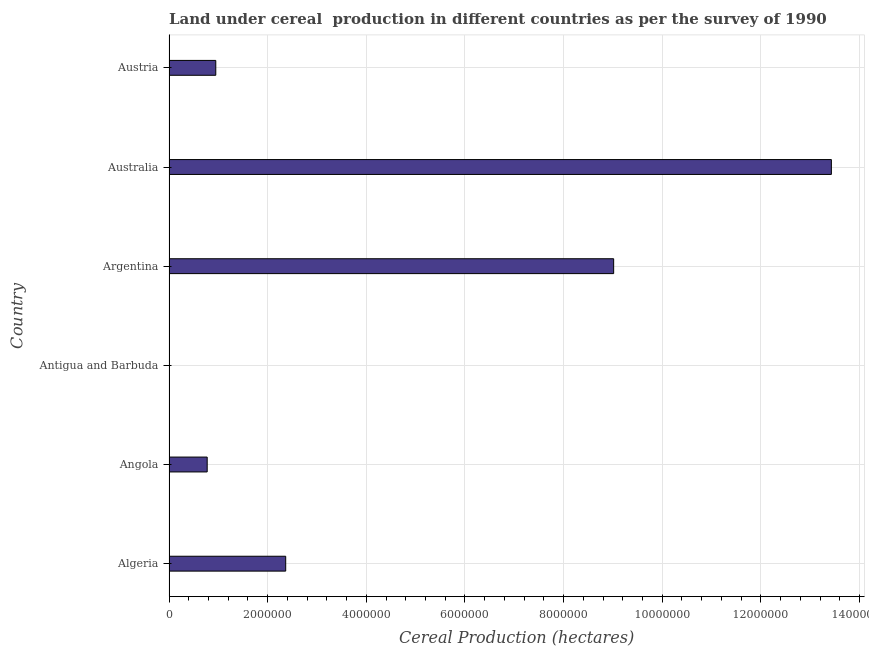Does the graph contain any zero values?
Your answer should be very brief. No. What is the title of the graph?
Provide a short and direct response. Land under cereal  production in different countries as per the survey of 1990. What is the label or title of the X-axis?
Your response must be concise. Cereal Production (hectares). What is the land under cereal production in Australia?
Your answer should be very brief. 1.34e+07. Across all countries, what is the maximum land under cereal production?
Your answer should be very brief. 1.34e+07. Across all countries, what is the minimum land under cereal production?
Provide a succinct answer. 21. In which country was the land under cereal production maximum?
Provide a succinct answer. Australia. In which country was the land under cereal production minimum?
Your response must be concise. Antigua and Barbuda. What is the sum of the land under cereal production?
Provide a short and direct response. 2.65e+07. What is the difference between the land under cereal production in Antigua and Barbuda and Austria?
Make the answer very short. -9.48e+05. What is the average land under cereal production per country?
Ensure brevity in your answer.  4.42e+06. What is the median land under cereal production?
Provide a short and direct response. 1.66e+06. In how many countries, is the land under cereal production greater than 9600000 hectares?
Provide a short and direct response. 1. What is the ratio of the land under cereal production in Algeria to that in Angola?
Keep it short and to the point. 3.06. Is the difference between the land under cereal production in Algeria and Angola greater than the difference between any two countries?
Provide a short and direct response. No. What is the difference between the highest and the second highest land under cereal production?
Give a very brief answer. 4.41e+06. What is the difference between the highest and the lowest land under cereal production?
Offer a very short reply. 1.34e+07. In how many countries, is the land under cereal production greater than the average land under cereal production taken over all countries?
Your answer should be very brief. 2. How many bars are there?
Ensure brevity in your answer.  6. Are the values on the major ticks of X-axis written in scientific E-notation?
Make the answer very short. No. What is the Cereal Production (hectares) of Algeria?
Offer a terse response. 2.37e+06. What is the Cereal Production (hectares) in Angola?
Keep it short and to the point. 7.74e+05. What is the Cereal Production (hectares) of Argentina?
Offer a terse response. 9.01e+06. What is the Cereal Production (hectares) in Australia?
Provide a short and direct response. 1.34e+07. What is the Cereal Production (hectares) of Austria?
Ensure brevity in your answer.  9.48e+05. What is the difference between the Cereal Production (hectares) in Algeria and Angola?
Make the answer very short. 1.59e+06. What is the difference between the Cereal Production (hectares) in Algeria and Antigua and Barbuda?
Provide a short and direct response. 2.37e+06. What is the difference between the Cereal Production (hectares) in Algeria and Argentina?
Offer a very short reply. -6.65e+06. What is the difference between the Cereal Production (hectares) in Algeria and Australia?
Your response must be concise. -1.11e+07. What is the difference between the Cereal Production (hectares) in Algeria and Austria?
Offer a very short reply. 1.42e+06. What is the difference between the Cereal Production (hectares) in Angola and Antigua and Barbuda?
Provide a succinct answer. 7.74e+05. What is the difference between the Cereal Production (hectares) in Angola and Argentina?
Offer a terse response. -8.24e+06. What is the difference between the Cereal Production (hectares) in Angola and Australia?
Your response must be concise. -1.27e+07. What is the difference between the Cereal Production (hectares) in Angola and Austria?
Your response must be concise. -1.74e+05. What is the difference between the Cereal Production (hectares) in Antigua and Barbuda and Argentina?
Provide a succinct answer. -9.01e+06. What is the difference between the Cereal Production (hectares) in Antigua and Barbuda and Australia?
Offer a very short reply. -1.34e+07. What is the difference between the Cereal Production (hectares) in Antigua and Barbuda and Austria?
Your response must be concise. -9.48e+05. What is the difference between the Cereal Production (hectares) in Argentina and Australia?
Offer a very short reply. -4.41e+06. What is the difference between the Cereal Production (hectares) in Argentina and Austria?
Your response must be concise. 8.07e+06. What is the difference between the Cereal Production (hectares) in Australia and Austria?
Ensure brevity in your answer.  1.25e+07. What is the ratio of the Cereal Production (hectares) in Algeria to that in Angola?
Provide a succinct answer. 3.06. What is the ratio of the Cereal Production (hectares) in Algeria to that in Antigua and Barbuda?
Provide a short and direct response. 1.13e+05. What is the ratio of the Cereal Production (hectares) in Algeria to that in Argentina?
Offer a terse response. 0.26. What is the ratio of the Cereal Production (hectares) in Algeria to that in Australia?
Your answer should be compact. 0.18. What is the ratio of the Cereal Production (hectares) in Algeria to that in Austria?
Your answer should be very brief. 2.5. What is the ratio of the Cereal Production (hectares) in Angola to that in Antigua and Barbuda?
Offer a terse response. 3.69e+04. What is the ratio of the Cereal Production (hectares) in Angola to that in Argentina?
Provide a succinct answer. 0.09. What is the ratio of the Cereal Production (hectares) in Angola to that in Australia?
Your answer should be compact. 0.06. What is the ratio of the Cereal Production (hectares) in Angola to that in Austria?
Your answer should be very brief. 0.82. What is the ratio of the Cereal Production (hectares) in Antigua and Barbuda to that in Argentina?
Offer a very short reply. 0. What is the ratio of the Cereal Production (hectares) in Antigua and Barbuda to that in Australia?
Provide a short and direct response. 0. What is the ratio of the Cereal Production (hectares) in Argentina to that in Australia?
Your answer should be compact. 0.67. What is the ratio of the Cereal Production (hectares) in Argentina to that in Austria?
Provide a succinct answer. 9.51. What is the ratio of the Cereal Production (hectares) in Australia to that in Austria?
Provide a succinct answer. 14.16. 